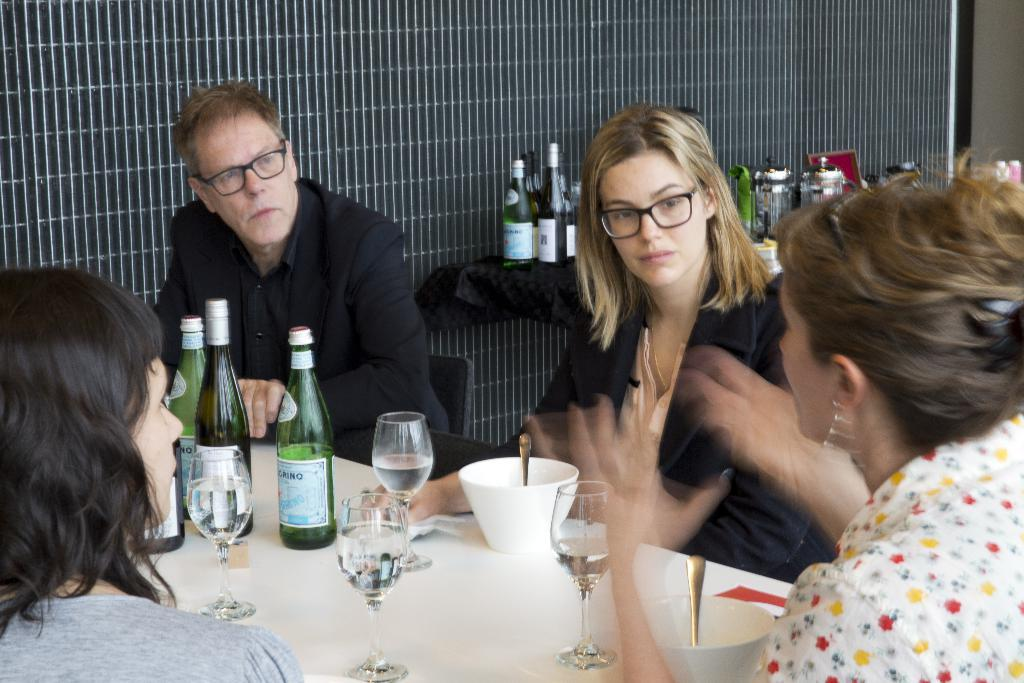How many people are present in the image? There are four people in the image. What objects can be seen on the table in the image? There are bottles, glasses, bowls, and spoons on the table in the image. What is the color of the tablecloth covering the table? The table is covered with a black cloth. What type of trucks are parked outside the window in the image? There are no trucks visible in the image, as it only shows a table with people and objects. 